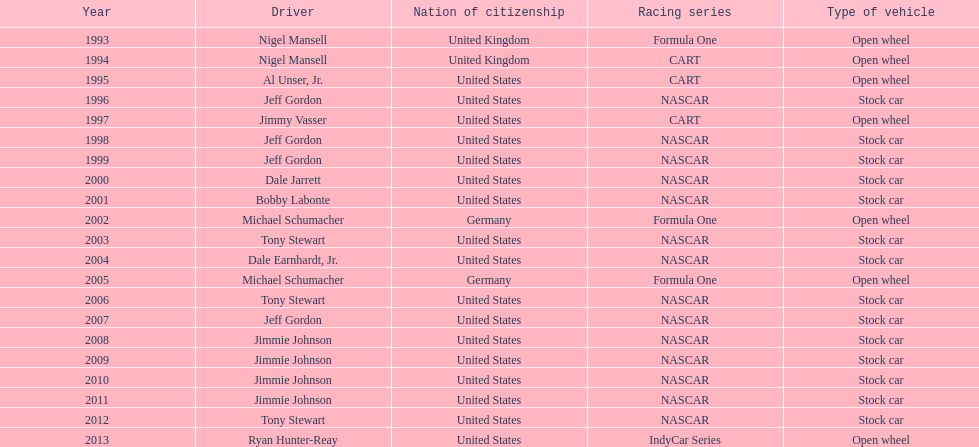Which racer achieved espy awards victories with an 11-year separation? Jeff Gordon. 